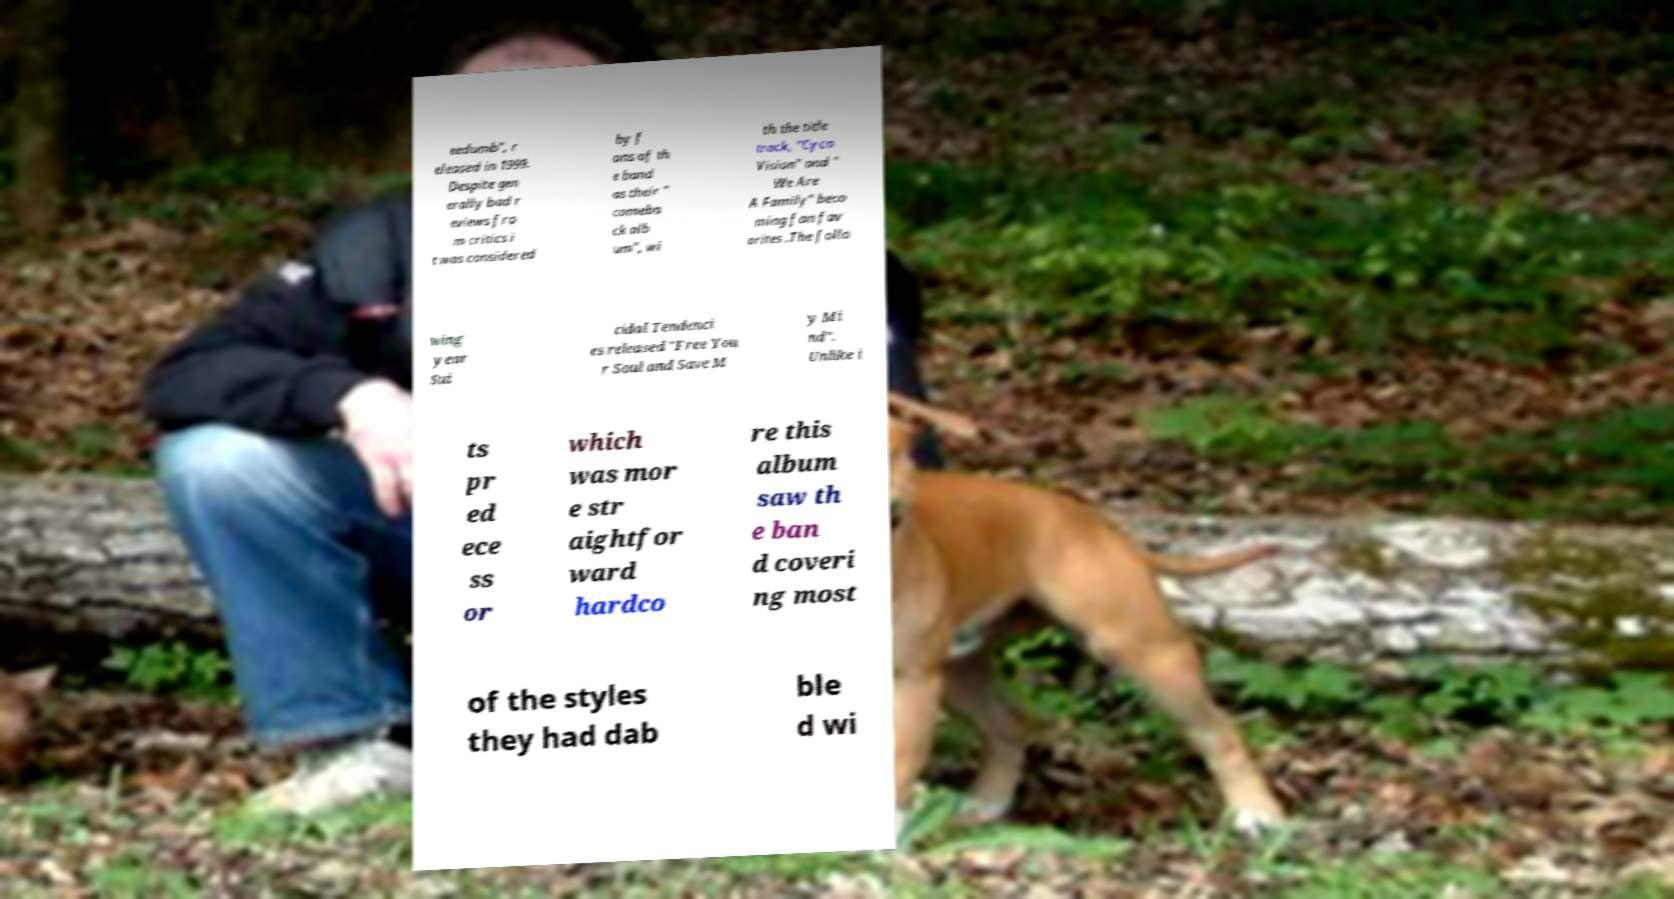For documentation purposes, I need the text within this image transcribed. Could you provide that? eedumb", r eleased in 1999. Despite gen erally bad r eviews fro m critics i t was considered by f ans of th e band as their " comeba ck alb um", wi th the title track, "Cyco Vision" and " We Are A Family" beco ming fan fav orites .The follo wing year Sui cidal Tendenci es released "Free You r Soul and Save M y Mi nd". Unlike i ts pr ed ece ss or which was mor e str aightfor ward hardco re this album saw th e ban d coveri ng most of the styles they had dab ble d wi 